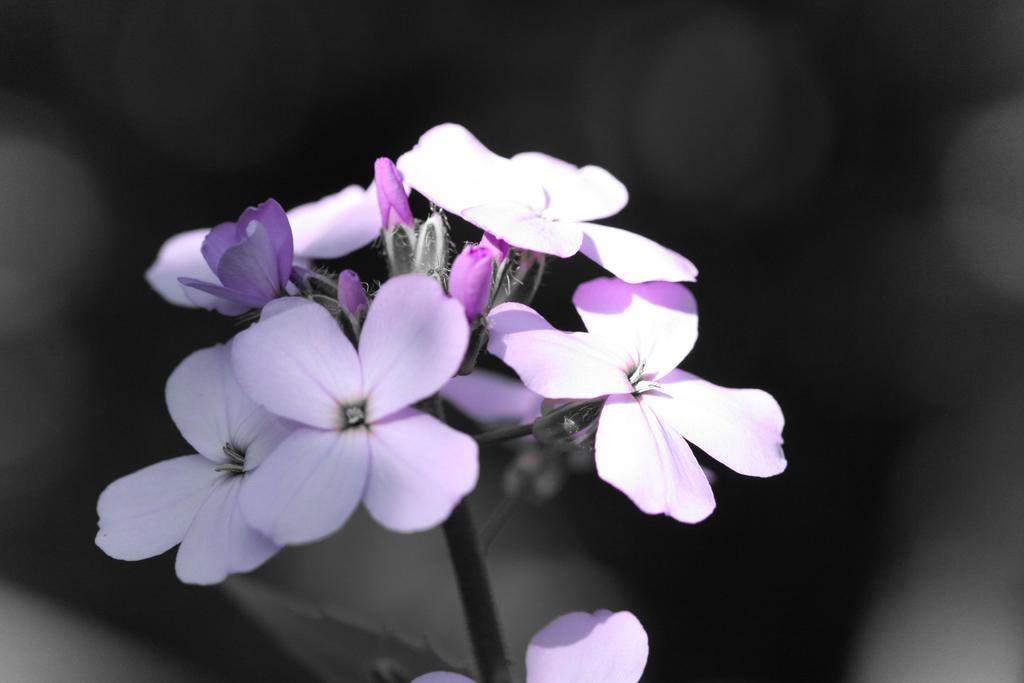In one or two sentences, can you explain what this image depicts? In this image in the front there are flowers. 